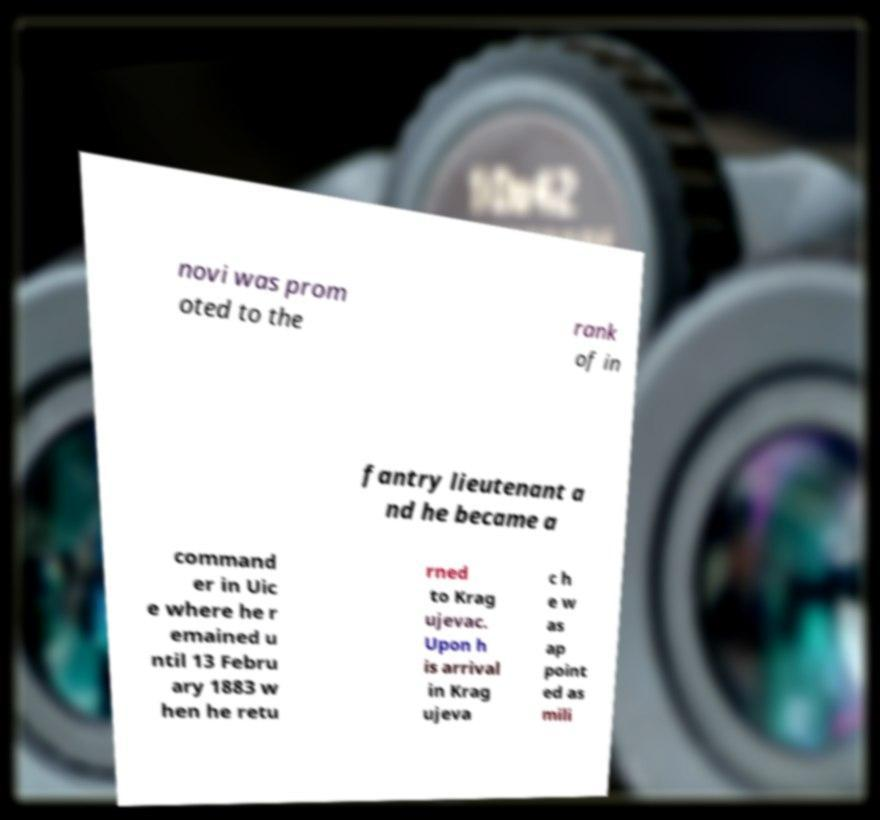For documentation purposes, I need the text within this image transcribed. Could you provide that? novi was prom oted to the rank of in fantry lieutenant a nd he became a command er in Uic e where he r emained u ntil 13 Febru ary 1883 w hen he retu rned to Krag ujevac. Upon h is arrival in Krag ujeva c h e w as ap point ed as mili 